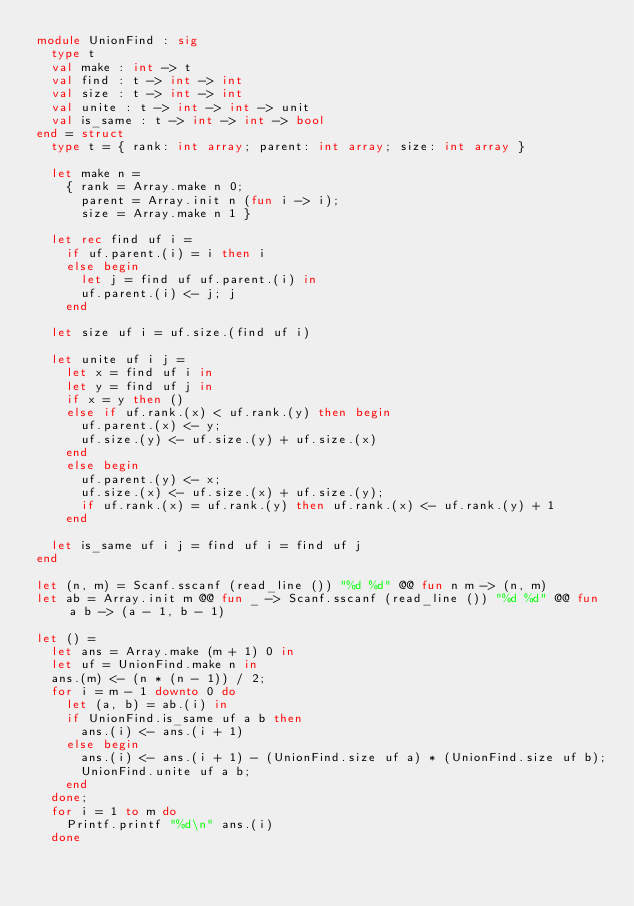Convert code to text. <code><loc_0><loc_0><loc_500><loc_500><_OCaml_>module UnionFind : sig
  type t
  val make : int -> t
  val find : t -> int -> int
  val size : t -> int -> int
  val unite : t -> int -> int -> unit
  val is_same : t -> int -> int -> bool
end = struct
  type t = { rank: int array; parent: int array; size: int array }

  let make n = 
    { rank = Array.make n 0; 
      parent = Array.init n (fun i -> i);
      size = Array.make n 1 }

  let rec find uf i = 
    if uf.parent.(i) = i then i
    else begin
      let j = find uf uf.parent.(i) in 
      uf.parent.(i) <- j; j
    end
  
  let size uf i = uf.size.(find uf i)

  let unite uf i j =
    let x = find uf i in
    let y = find uf j in
    if x = y then ()
    else if uf.rank.(x) < uf.rank.(y) then begin
      uf.parent.(x) <- y;
      uf.size.(y) <- uf.size.(y) + uf.size.(x)
    end
    else begin
      uf.parent.(y) <- x;
      uf.size.(x) <- uf.size.(x) + uf.size.(y);
      if uf.rank.(x) = uf.rank.(y) then uf.rank.(x) <- uf.rank.(y) + 1
    end

  let is_same uf i j = find uf i = find uf j
end

let (n, m) = Scanf.sscanf (read_line ()) "%d %d" @@ fun n m -> (n, m)
let ab = Array.init m @@ fun _ -> Scanf.sscanf (read_line ()) "%d %d" @@ fun a b -> (a - 1, b - 1)

let () =
  let ans = Array.make (m + 1) 0 in
  let uf = UnionFind.make n in
  ans.(m) <- (n * (n - 1)) / 2;
  for i = m - 1 downto 0 do
    let (a, b) = ab.(i) in
    if UnionFind.is_same uf a b then
      ans.(i) <- ans.(i + 1)
    else begin
      ans.(i) <- ans.(i + 1) - (UnionFind.size uf a) * (UnionFind.size uf b);
      UnionFind.unite uf a b;
    end
  done;
  for i = 1 to m do
    Printf.printf "%d\n" ans.(i)
  done</code> 